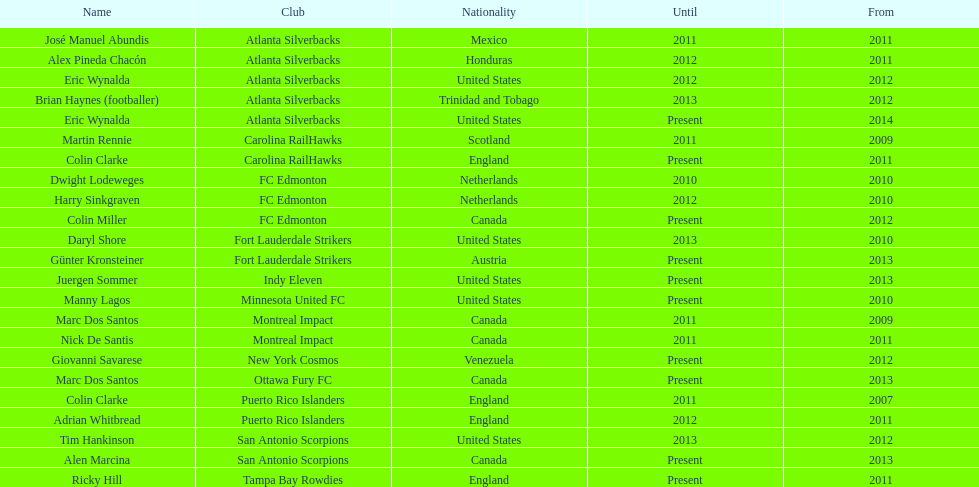What name is listed at the top? José Manuel Abundis. 